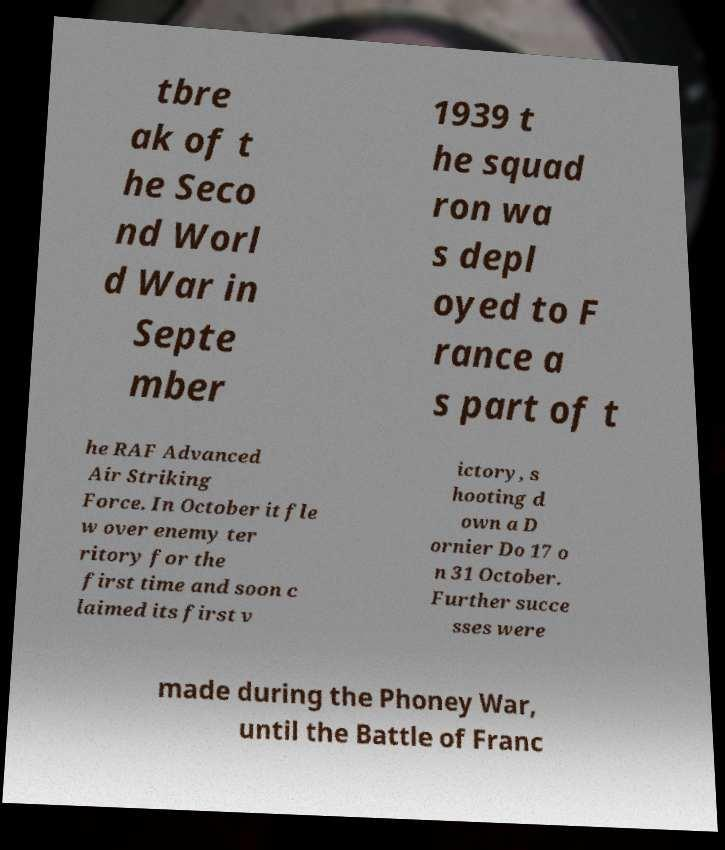What messages or text are displayed in this image? I need them in a readable, typed format. tbre ak of t he Seco nd Worl d War in Septe mber 1939 t he squad ron wa s depl oyed to F rance a s part of t he RAF Advanced Air Striking Force. In October it fle w over enemy ter ritory for the first time and soon c laimed its first v ictory, s hooting d own a D ornier Do 17 o n 31 October. Further succe sses were made during the Phoney War, until the Battle of Franc 